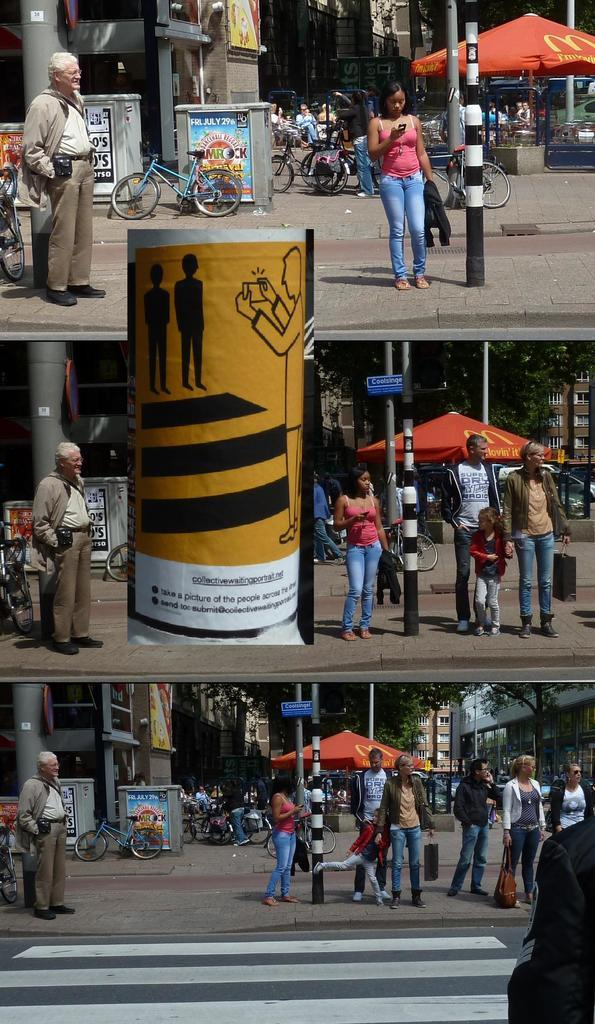<image>
Create a compact narrative representing the image presented. The red umbrella in the back ground is from McDonalds 